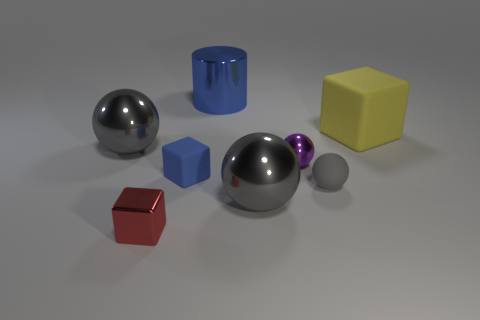Subtract all purple balls. How many balls are left? 3 Subtract all blue cubes. How many gray spheres are left? 3 Subtract all gray balls. How many balls are left? 1 Add 2 red shiny objects. How many objects exist? 10 Subtract all cylinders. How many objects are left? 7 Subtract 2 balls. How many balls are left? 2 Add 5 small red metal things. How many small red metal things exist? 6 Subtract 0 brown blocks. How many objects are left? 8 Subtract all brown cubes. Subtract all yellow balls. How many cubes are left? 3 Subtract all big cyan matte balls. Subtract all large objects. How many objects are left? 4 